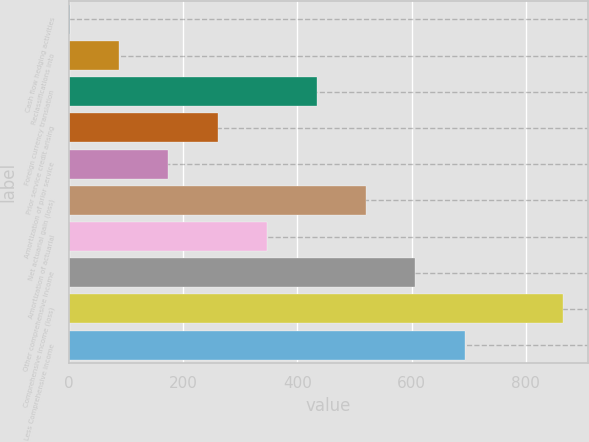Convert chart. <chart><loc_0><loc_0><loc_500><loc_500><bar_chart><fcel>Cash flow hedging activities<fcel>Reclassifications into<fcel>Foreign currency translation<fcel>Prior service credit arising<fcel>Amortization of prior service<fcel>Net actuarial gain (loss)<fcel>Amortization of actuarial<fcel>Other comprehensive income<fcel>Comprehensive income (loss)<fcel>Less Comprehensive income<nl><fcel>1<fcel>87.5<fcel>433.5<fcel>260.5<fcel>174<fcel>520<fcel>347<fcel>606.5<fcel>866<fcel>693<nl></chart> 